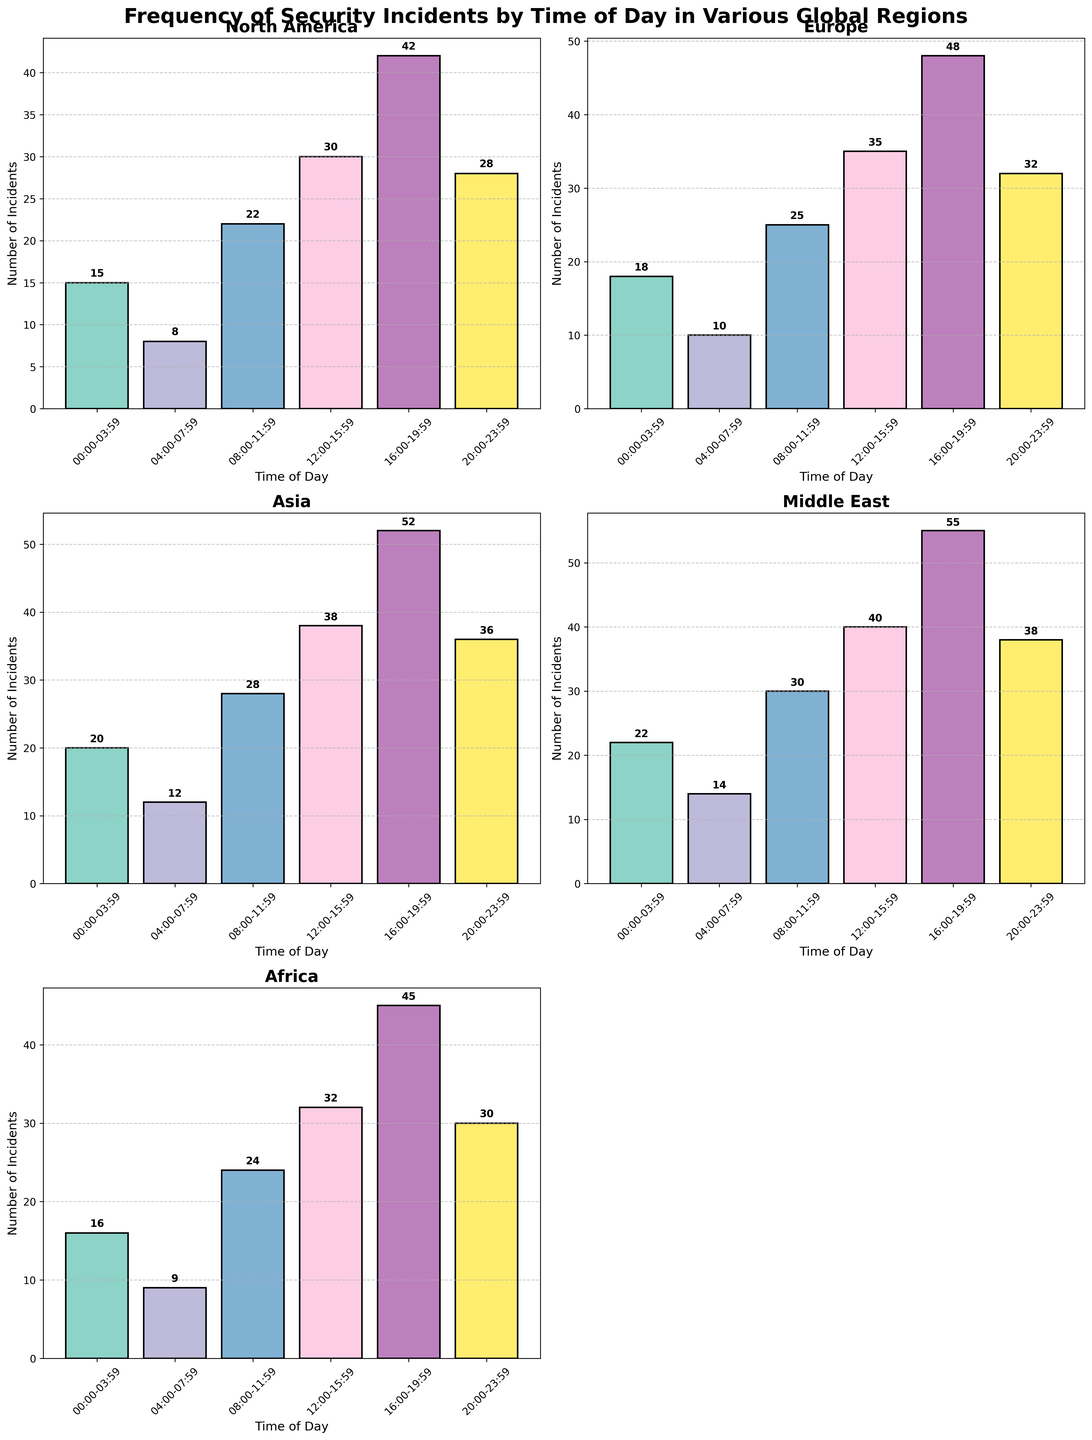What is the title of the figure? The title is located at the top of the figure, describing the overall content of the plot. It reads "Frequency of Security Incidents by Time of Day in Various Global Regions."
Answer: Frequency of Security Incidents by Time of Day in Various Global Regions Which region has the highest number of security incidents in the 16:00-19:59 time slot? By looking at the subplots, find the 16:00-19:59 time slot bar in each subplot and compare their heights. The Middle East has 55 incidents, the highest among all regions.
Answer: Middle East During which time slot does North America experience the fewest security incidents? In the North America subplot, compare the heights of all bars to find the shortest one. The 04:00-07:59 time slot has the fewest incidents with 8.
Answer: 04:00-07:59 How many security incidents occur in Asia from 08:00 to 15:59 combined? In the Asia subplot, sum the number of incidents for the slots 08:00-11:59 (28 incidents) and 12:00-15:59 (38 incidents). 28 + 38 = 66.
Answer: 66 In terms of the total number of incidents throughout the day, how does Europe compare to Africa? Sum the incidents for each time slot in both Europe and Africa subplots, then compare the totals. Europe: 18 + 10 + 25 + 35 + 48 + 32 = 168; Africa: 16 + 9 + 24 + 32 + 45 + 30 = 156. Europe has more incidents.
Answer: Europe has more incidents Which time slot is the busiest for all regions combined? Sum the incidents for each time slot across all regions, then compare to find the highest sum. The 16:00-19:59 slot has the highest combined total: 42 (NA) + 48 (EU) + 52 (Asia) + 55 (ME) + 45 (Africa) = 242.
Answer: 16:00-19:59 What is the median number of incidents for the 12:00-15:59 slot across all regions? Identify the 12:00-15:59 slot for each region and list their incidents: 30 (NA), 35 (EU), 38 (Asia), 40 (ME), 32 (Africa). Arrange in order: 30, 32, 35, 38, 40. The median is the middle value, which is 35.
Answer: 35 Which region has the smallest range of incidents throughout the day? Calculate the range (max-min) of incidents for each region and find the smallest. North America: 42-8=34; Europe: 48-10=38; Asia: 52-12=40; Middle East: 55-14=41; Africa: 45-9=36. North America has the smallest range.
Answer: North America 